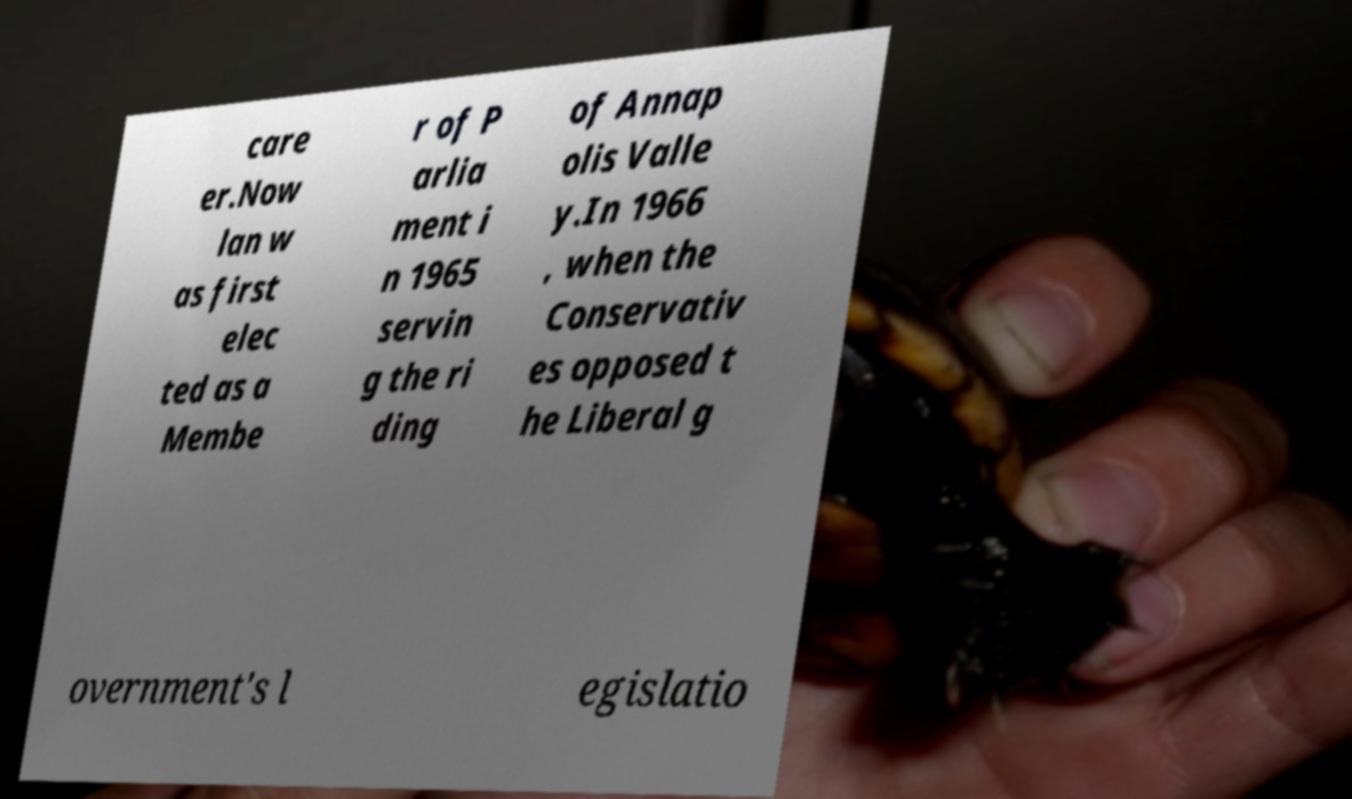Could you assist in decoding the text presented in this image and type it out clearly? care er.Now lan w as first elec ted as a Membe r of P arlia ment i n 1965 servin g the ri ding of Annap olis Valle y.In 1966 , when the Conservativ es opposed t he Liberal g overnment's l egislatio 